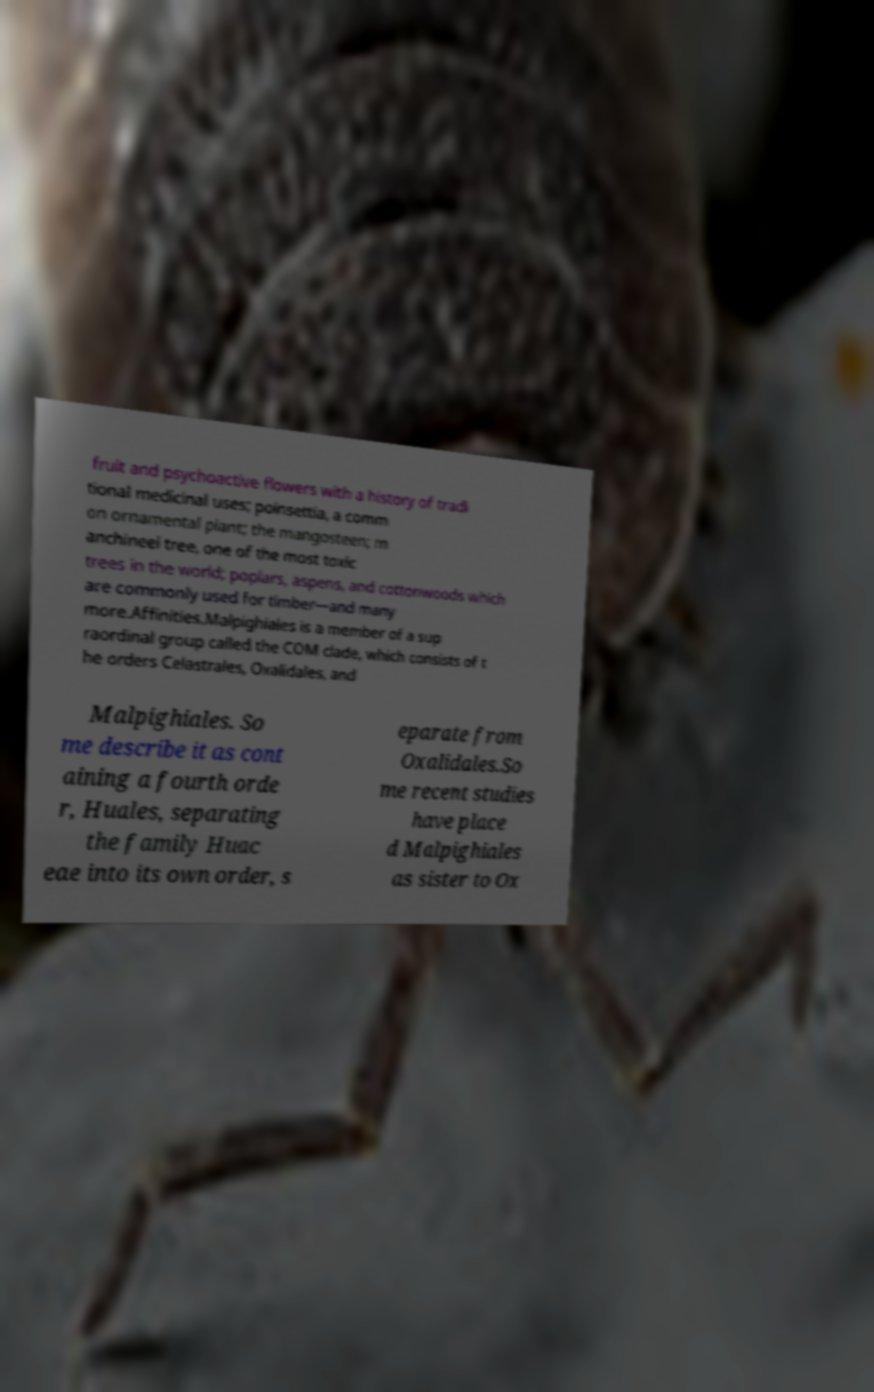Could you assist in decoding the text presented in this image and type it out clearly? fruit and psychoactive flowers with a history of tradi tional medicinal uses; poinsettia, a comm on ornamental plant; the mangosteen; m anchineel tree, one of the most toxic trees in the world; poplars, aspens, and cottonwoods which are commonly used for timber—and many more.Affinities.Malpighiales is a member of a sup raordinal group called the COM clade, which consists of t he orders Celastrales, Oxalidales, and Malpighiales. So me describe it as cont aining a fourth orde r, Huales, separating the family Huac eae into its own order, s eparate from Oxalidales.So me recent studies have place d Malpighiales as sister to Ox 